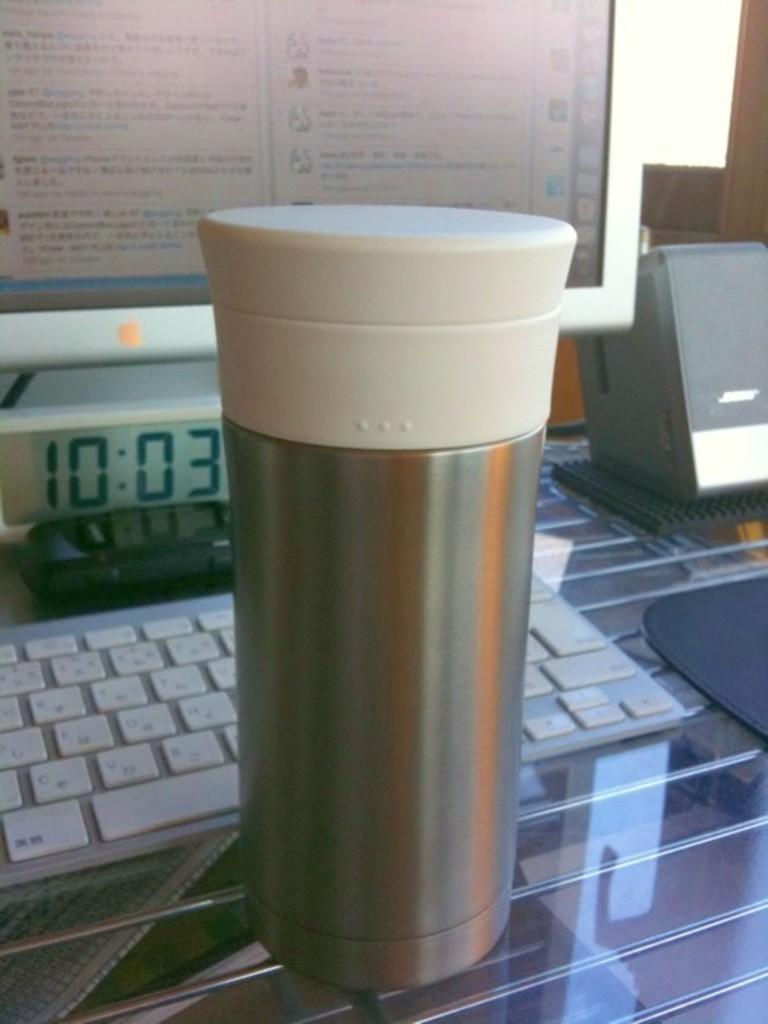<image>
Relay a brief, clear account of the picture shown. A stainless steel thermos sits on front of computer and a clock that reads 10:03 